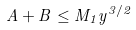Convert formula to latex. <formula><loc_0><loc_0><loc_500><loc_500>A + B \leq M _ { 1 } y ^ { 3 / 2 }</formula> 